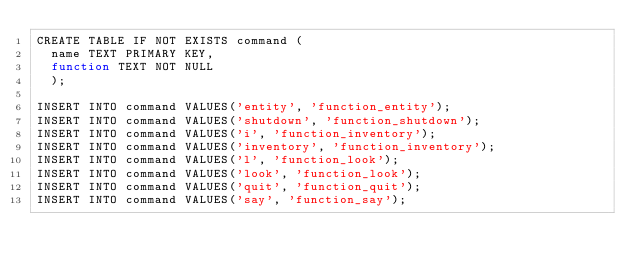<code> <loc_0><loc_0><loc_500><loc_500><_SQL_>CREATE TABLE IF NOT EXISTS command (
  name TEXT PRIMARY KEY,
  function TEXT NOT NULL
  );

INSERT INTO command VALUES('entity', 'function_entity');
INSERT INTO command VALUES('shutdown', 'function_shutdown');
INSERT INTO command VALUES('i', 'function_inventory');
INSERT INTO command VALUES('inventory', 'function_inventory');
INSERT INTO command VALUES('l', 'function_look');
INSERT INTO command VALUES('look', 'function_look');
INSERT INTO command VALUES('quit', 'function_quit');
INSERT INTO command VALUES('say', 'function_say');</code> 